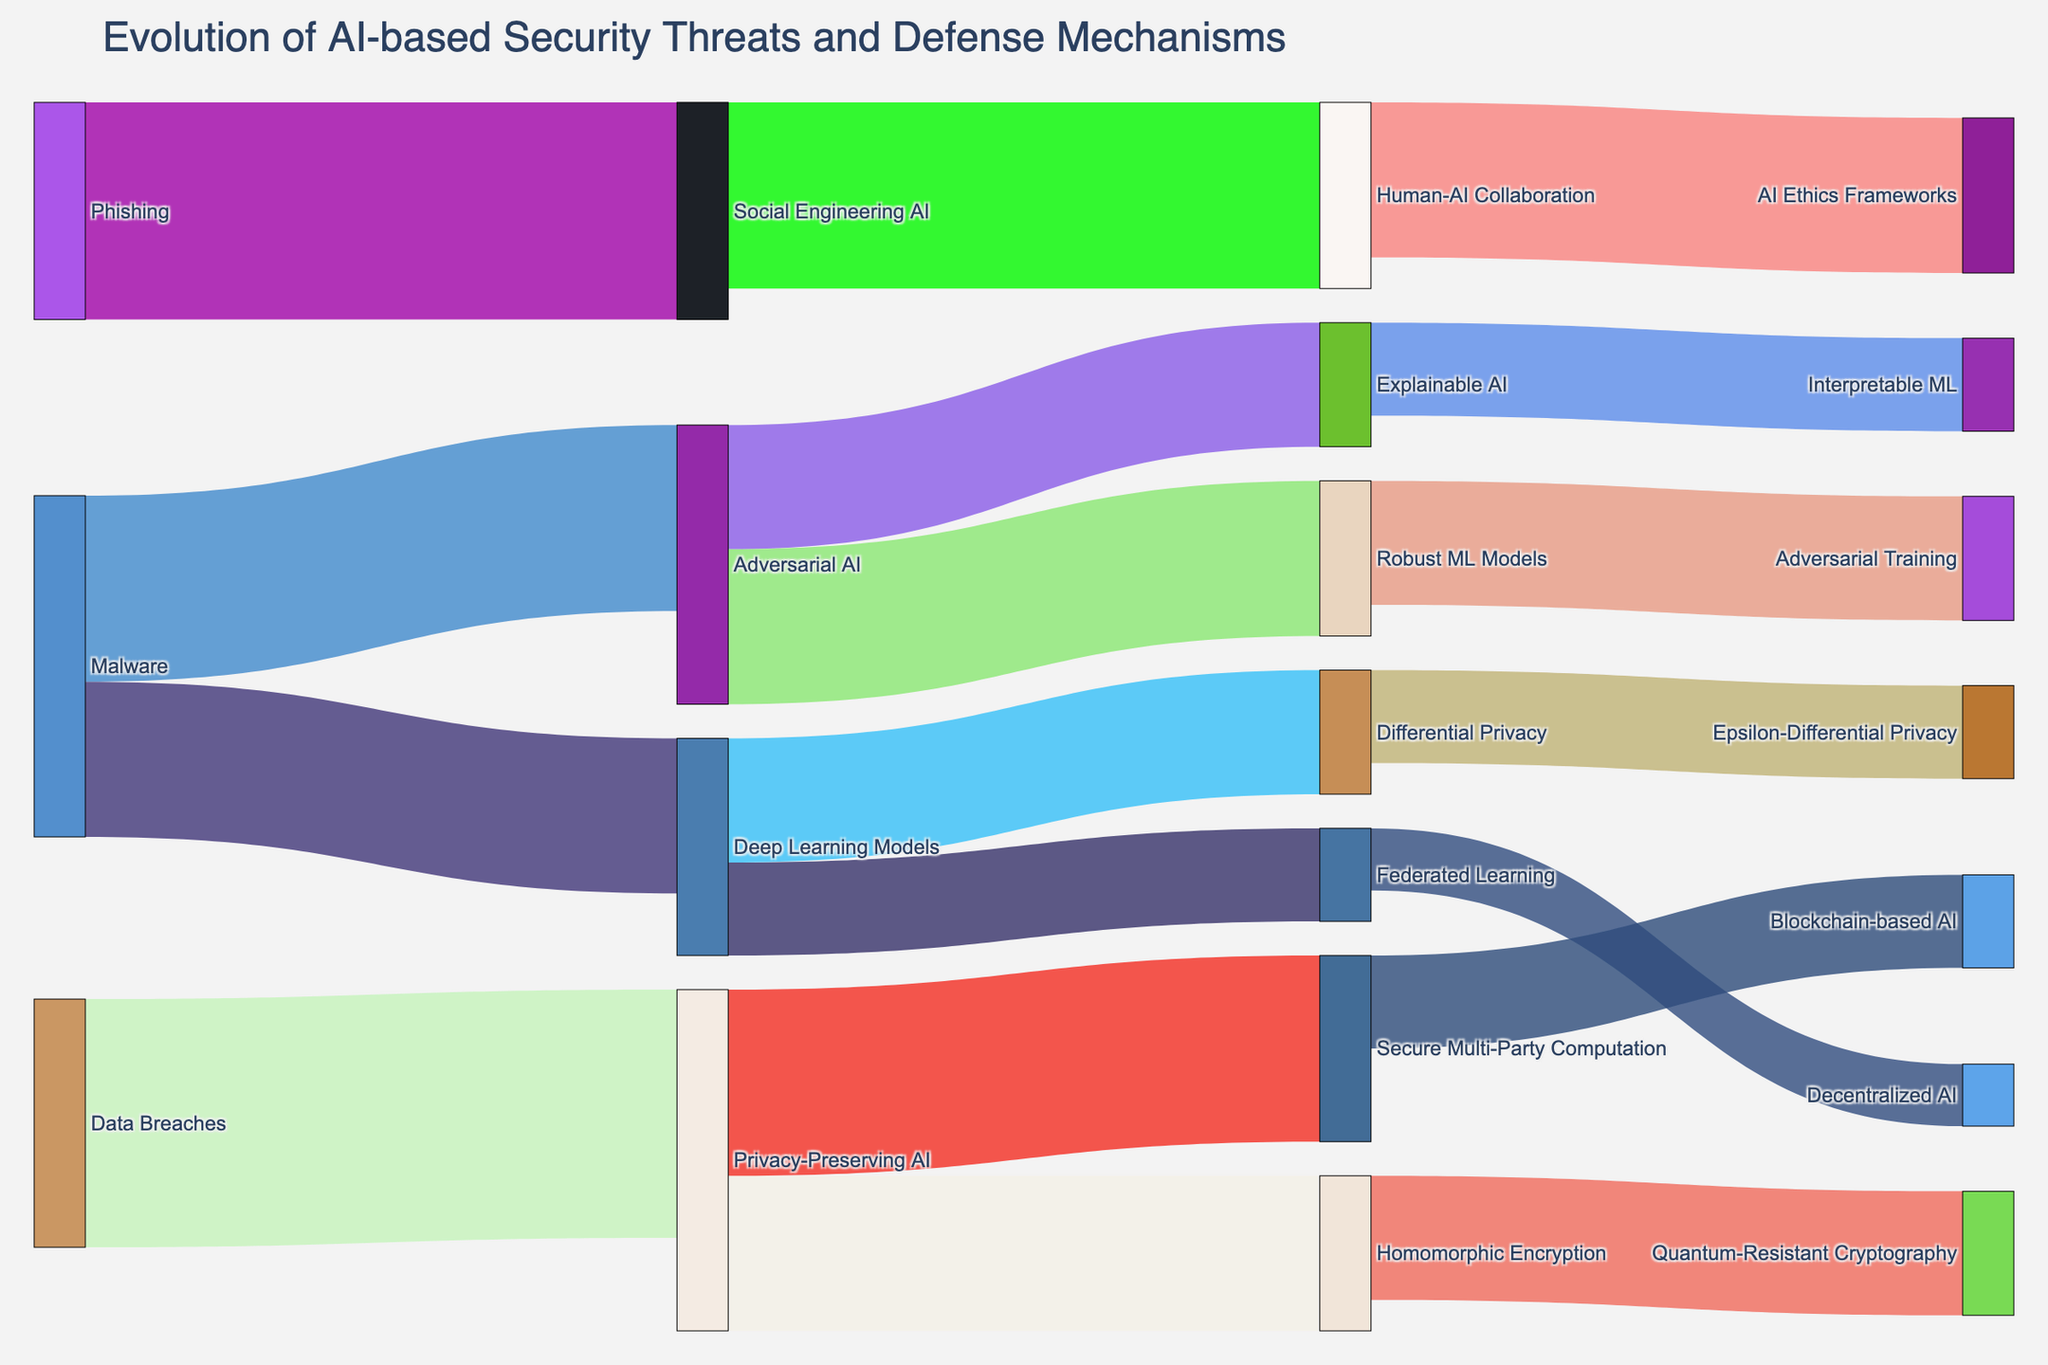What is the title of the Sankey diagram? The title is found at the top of the diagram and provides a summary of what the diagram represents.
Answer: Evolution of AI-based Security Threats and Defense Mechanisms Which threat has the highest associated defense mechanism in terms of value? Observe the flows from threats to defense mechanisms, and identify which source has the highest value flowing to its targets.
Answer: Data Breaches How many different defense mechanisms are shown in the diagram? Count all the unique targets (defense mechanisms) in the diagram.
Answer: 14 Which defense mechanism deals with 'Social Engineering AI'? Look for the flow originating from 'Social Engineering AI' and identify its target.
Answer: Human-AI Collaboration Compare the values of 'Adversarial AI' directed towards 'Explainable AI' and 'Robust ML Models'. Which is higher? Find the values directed from 'Adversarial AI' to both 'Explainable AI' and 'Robust ML Models', then compare them.
Answer: Robust ML Models What is the total value flowing from 'Deep Learning Models'? Sum the values of all flows originating from 'Deep Learning Models'.
Answer: 35 Is there a defense mechanism listed that addresses more than one AI-based security threat? If so, name it. Identify any target that appears in multiple flows from different sources.
Answer: Privacy-Preserving AI What is the combined value of mechanisms addressing 'Adversarial AI'? Sum the values of flows originating from 'Adversarial AI' towards all its targets.
Answer: 45 Which defense mechanism has the smallest value directed towards it, and what is the value? Find the defense mechanism with the smallest numerical value associated with it from any threat.
Answer: Decentralized AI, 10 Does 'Differential Privacy' have more or less value than 'Homomorphic Encryption'? Compare the individual values directed to 'Differential Privacy' and 'Homomorphic Encryption'.
Answer: Less 